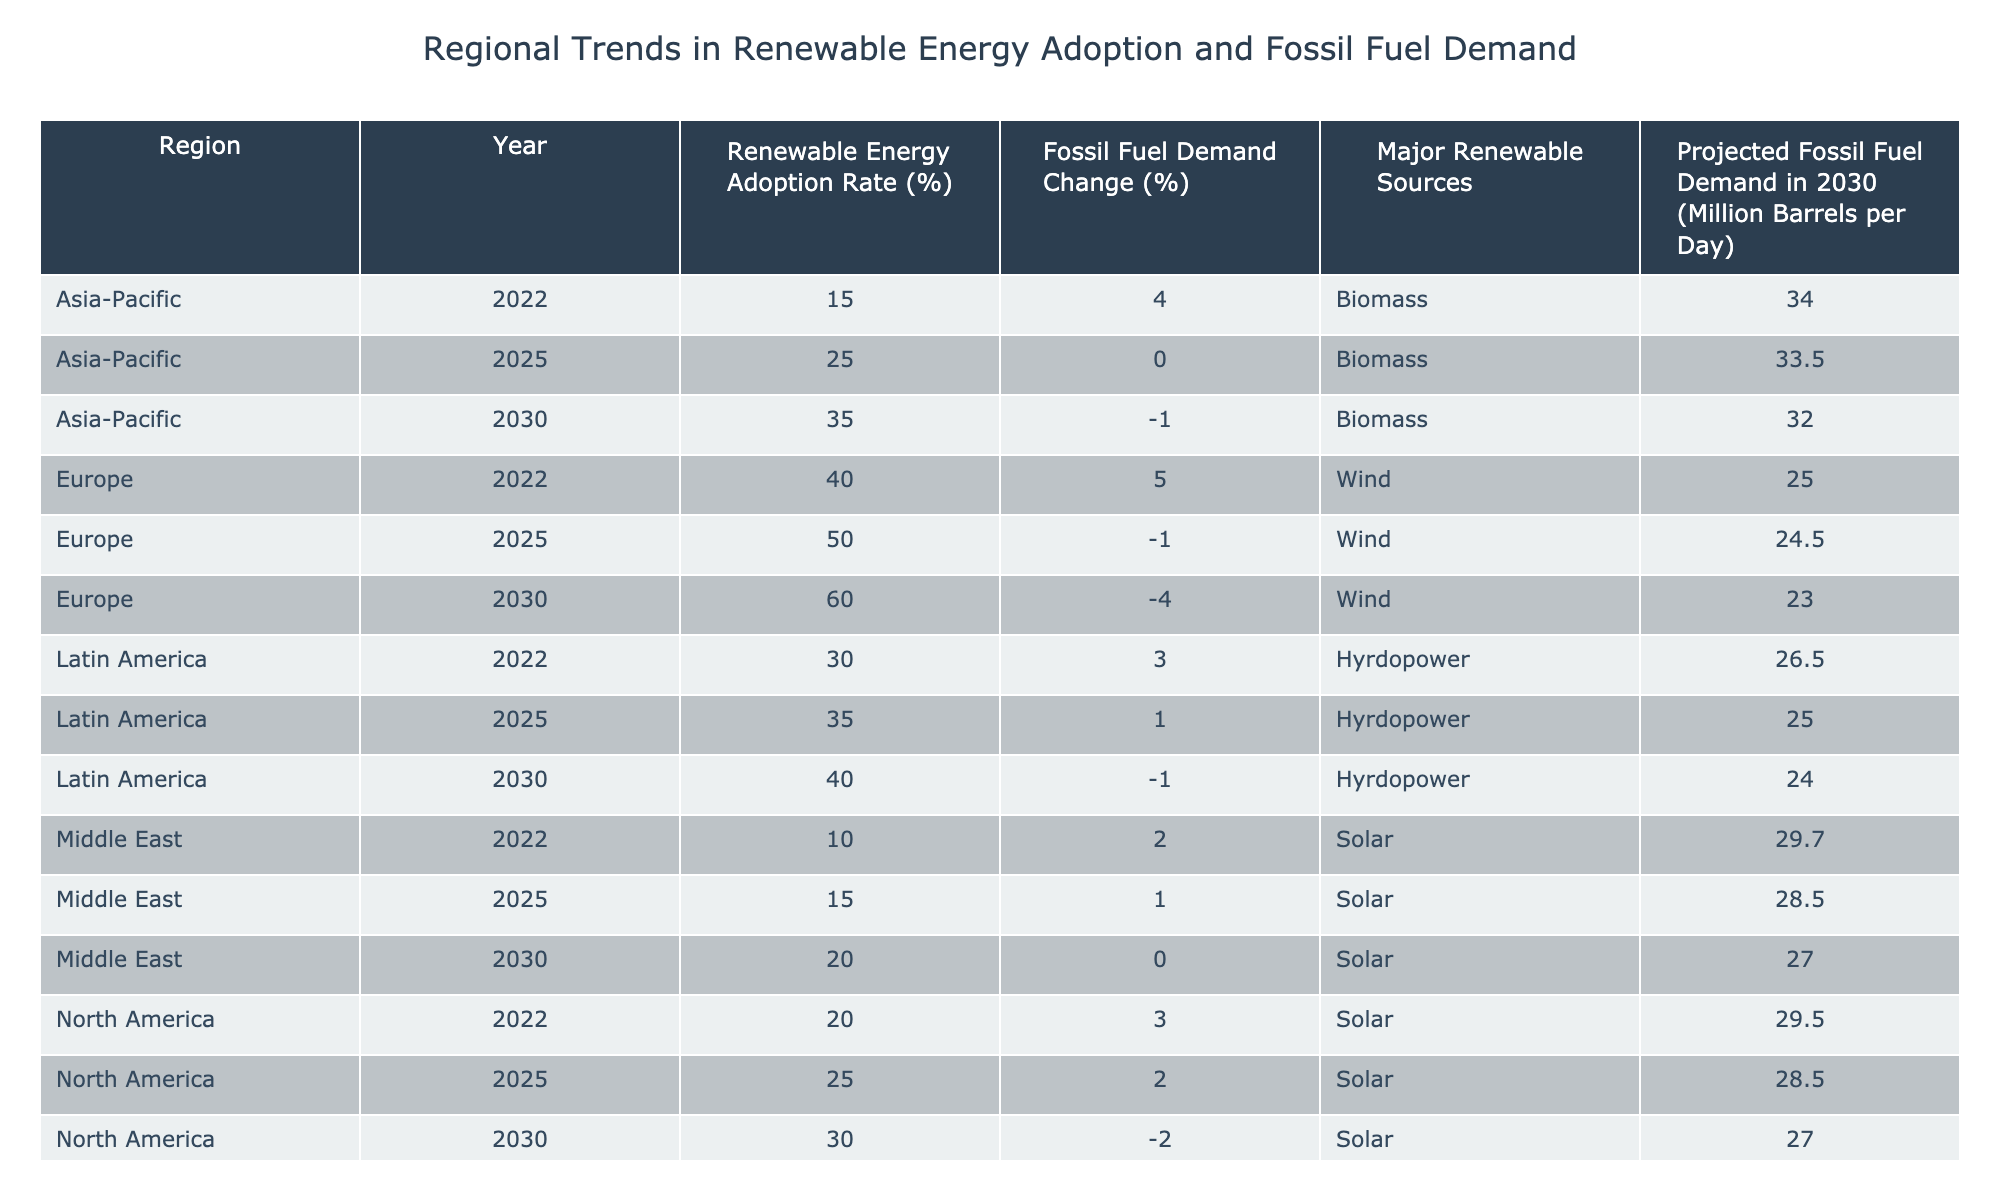What is the renewable energy adoption rate in Europe for the year 2025? The table shows a specific entry for Europe in the year 2025, where the renewable energy adoption rate is directly listed. Referring to that row, it indicates the rate is 50%.
Answer: 50% What is the major renewable source for Latin America in 2030? In the row for Latin America for the year 2030, the major renewable source is clearly specified within the table. It shows that the major renewable source is Hydropower.
Answer: Hydropower Which region has the highest projected fossil fuel demand in 2030? Looking at the projected fossil fuel demand for all regions in 2030, we find the values: North America (27.0 million barrels per day), Europe (23.0 million), Asia-Pacific (32.0 million), Middle East (27.0 million), and Latin America (24.0 million). The maximum is 32.0 million barrels per day in Asia-Pacific.
Answer: Asia-Pacific What was the change in fossil fuel demand for North America from 2025 to 2030? For North America, the fossil fuel demand change is listed as 2% for 2025 and -2% for 2030. To find the change, subtract the 2030 value from the 2025 value: -2% - 2% = -4%. This shows a decrease of 4%.
Answer: -4% Is the renewable energy adoption rate in Asia-Pacific higher in 2030 than in 2022? The renewable energy adoption rate in Asia-Pacific for 2022 is 15% and for 2030 it is 35%. Since 35% is greater than 15%, we can conclude the statement is true.
Answer: Yes What is the average renewable energy adoption rate across all regions for the year 2025? To calculate the average for 2025, we take the adoption rates: North America (25%), Europe (50%), Asia-Pacific (25%), Middle East (15%), and Latin America (35%). Adding these gives 25 + 50 + 25 + 15 + 35 = 150. Dividing by the number of regions (5) gives an average of 30%.
Answer: 30% In which year does Europe show a decrease in fossil fuel demand? In the table, the values of fossil fuel demand change for Europe are 5% in 2022, -1% in 2025, and -4% in 2030. The only years Europe experiences a decrease is 2025 and 2030, confirming this is true for both.
Answer: 2025 and 2030 What was the increase in renewable energy adoption rate for Latin America from 2022 to 2030? In 2022, Latin America has a renewable energy adoption rate of 30% and it rises to 40% in 2030. The change is calculated as 40% - 30% = 10%, indicating a 10% increase over this period.
Answer: 10% 